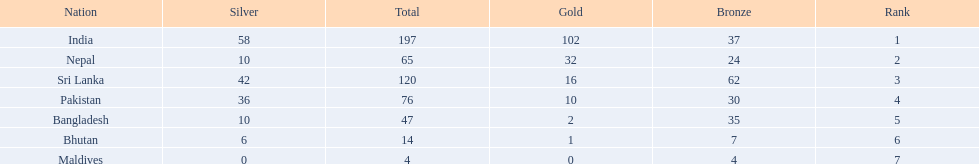What was the only nation to win less than 10 medals total? Maldives. 